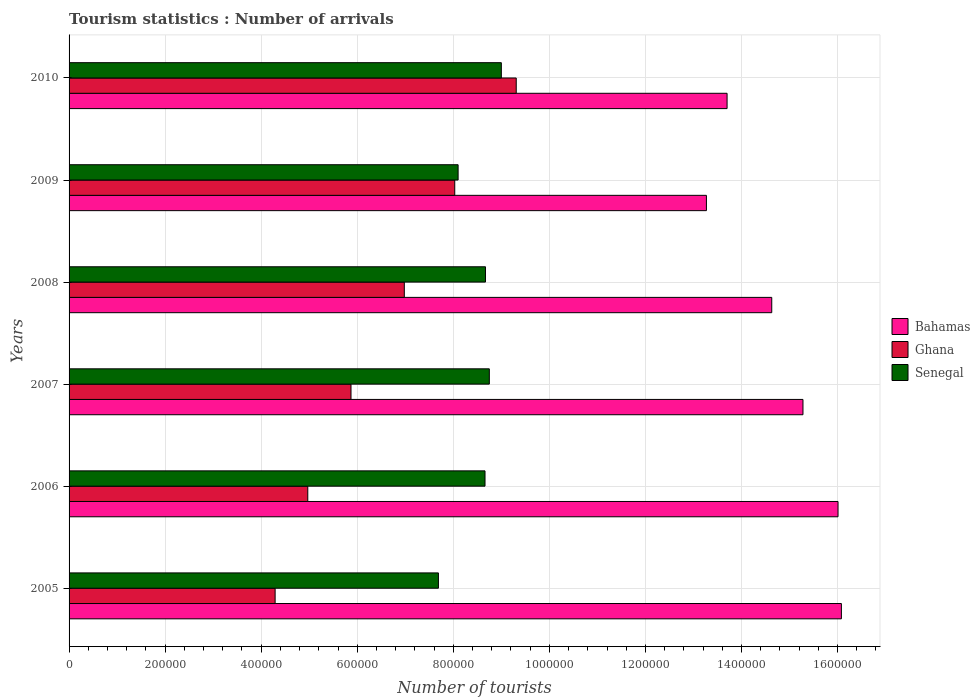How many different coloured bars are there?
Offer a terse response. 3. How many groups of bars are there?
Make the answer very short. 6. Are the number of bars per tick equal to the number of legend labels?
Give a very brief answer. Yes. How many bars are there on the 6th tick from the bottom?
Provide a short and direct response. 3. What is the label of the 2nd group of bars from the top?
Keep it short and to the point. 2009. What is the number of tourist arrivals in Senegal in 2008?
Your answer should be very brief. 8.67e+05. Across all years, what is the maximum number of tourist arrivals in Ghana?
Your answer should be very brief. 9.31e+05. Across all years, what is the minimum number of tourist arrivals in Ghana?
Offer a very short reply. 4.29e+05. What is the total number of tourist arrivals in Senegal in the graph?
Your response must be concise. 5.09e+06. What is the difference between the number of tourist arrivals in Senegal in 2005 and that in 2010?
Your answer should be very brief. -1.31e+05. What is the difference between the number of tourist arrivals in Bahamas in 2005 and the number of tourist arrivals in Ghana in 2008?
Give a very brief answer. 9.10e+05. What is the average number of tourist arrivals in Senegal per year?
Ensure brevity in your answer.  8.48e+05. In the year 2010, what is the difference between the number of tourist arrivals in Bahamas and number of tourist arrivals in Ghana?
Keep it short and to the point. 4.39e+05. What is the ratio of the number of tourist arrivals in Senegal in 2005 to that in 2009?
Give a very brief answer. 0.95. Is the number of tourist arrivals in Ghana in 2006 less than that in 2009?
Your response must be concise. Yes. Is the difference between the number of tourist arrivals in Bahamas in 2006 and 2009 greater than the difference between the number of tourist arrivals in Ghana in 2006 and 2009?
Make the answer very short. Yes. What is the difference between the highest and the second highest number of tourist arrivals in Ghana?
Provide a succinct answer. 1.28e+05. What is the difference between the highest and the lowest number of tourist arrivals in Bahamas?
Keep it short and to the point. 2.81e+05. What does the 2nd bar from the bottom in 2010 represents?
Keep it short and to the point. Ghana. Is it the case that in every year, the sum of the number of tourist arrivals in Senegal and number of tourist arrivals in Bahamas is greater than the number of tourist arrivals in Ghana?
Keep it short and to the point. Yes. Are all the bars in the graph horizontal?
Provide a succinct answer. Yes. Are the values on the major ticks of X-axis written in scientific E-notation?
Your response must be concise. No. Does the graph contain any zero values?
Your answer should be compact. No. Does the graph contain grids?
Offer a terse response. Yes. Where does the legend appear in the graph?
Offer a very short reply. Center right. How many legend labels are there?
Your response must be concise. 3. What is the title of the graph?
Provide a succinct answer. Tourism statistics : Number of arrivals. What is the label or title of the X-axis?
Provide a succinct answer. Number of tourists. What is the label or title of the Y-axis?
Your response must be concise. Years. What is the Number of tourists in Bahamas in 2005?
Offer a very short reply. 1.61e+06. What is the Number of tourists of Ghana in 2005?
Make the answer very short. 4.29e+05. What is the Number of tourists in Senegal in 2005?
Offer a terse response. 7.69e+05. What is the Number of tourists in Bahamas in 2006?
Ensure brevity in your answer.  1.60e+06. What is the Number of tourists in Ghana in 2006?
Offer a terse response. 4.97e+05. What is the Number of tourists in Senegal in 2006?
Offer a terse response. 8.66e+05. What is the Number of tourists of Bahamas in 2007?
Keep it short and to the point. 1.53e+06. What is the Number of tourists in Ghana in 2007?
Make the answer very short. 5.87e+05. What is the Number of tourists in Senegal in 2007?
Make the answer very short. 8.75e+05. What is the Number of tourists in Bahamas in 2008?
Offer a terse response. 1.46e+06. What is the Number of tourists of Ghana in 2008?
Your answer should be very brief. 6.98e+05. What is the Number of tourists in Senegal in 2008?
Provide a succinct answer. 8.67e+05. What is the Number of tourists of Bahamas in 2009?
Provide a succinct answer. 1.33e+06. What is the Number of tourists of Ghana in 2009?
Offer a terse response. 8.03e+05. What is the Number of tourists of Senegal in 2009?
Give a very brief answer. 8.10e+05. What is the Number of tourists of Bahamas in 2010?
Keep it short and to the point. 1.37e+06. What is the Number of tourists in Ghana in 2010?
Offer a terse response. 9.31e+05. What is the Number of tourists in Senegal in 2010?
Your response must be concise. 9.00e+05. Across all years, what is the maximum Number of tourists in Bahamas?
Provide a short and direct response. 1.61e+06. Across all years, what is the maximum Number of tourists in Ghana?
Offer a very short reply. 9.31e+05. Across all years, what is the minimum Number of tourists in Bahamas?
Offer a very short reply. 1.33e+06. Across all years, what is the minimum Number of tourists in Ghana?
Offer a very short reply. 4.29e+05. Across all years, what is the minimum Number of tourists in Senegal?
Provide a short and direct response. 7.69e+05. What is the total Number of tourists of Bahamas in the graph?
Your answer should be very brief. 8.90e+06. What is the total Number of tourists of Ghana in the graph?
Provide a succinct answer. 3.94e+06. What is the total Number of tourists of Senegal in the graph?
Ensure brevity in your answer.  5.09e+06. What is the difference between the Number of tourists of Bahamas in 2005 and that in 2006?
Your answer should be compact. 7000. What is the difference between the Number of tourists of Ghana in 2005 and that in 2006?
Offer a very short reply. -6.80e+04. What is the difference between the Number of tourists in Senegal in 2005 and that in 2006?
Provide a succinct answer. -9.70e+04. What is the difference between the Number of tourists in Bahamas in 2005 and that in 2007?
Your response must be concise. 8.00e+04. What is the difference between the Number of tourists of Ghana in 2005 and that in 2007?
Make the answer very short. -1.58e+05. What is the difference between the Number of tourists of Senegal in 2005 and that in 2007?
Your response must be concise. -1.06e+05. What is the difference between the Number of tourists of Bahamas in 2005 and that in 2008?
Ensure brevity in your answer.  1.45e+05. What is the difference between the Number of tourists of Ghana in 2005 and that in 2008?
Offer a terse response. -2.69e+05. What is the difference between the Number of tourists in Senegal in 2005 and that in 2008?
Provide a succinct answer. -9.80e+04. What is the difference between the Number of tourists of Bahamas in 2005 and that in 2009?
Your answer should be very brief. 2.81e+05. What is the difference between the Number of tourists of Ghana in 2005 and that in 2009?
Your answer should be very brief. -3.74e+05. What is the difference between the Number of tourists of Senegal in 2005 and that in 2009?
Your answer should be compact. -4.10e+04. What is the difference between the Number of tourists in Bahamas in 2005 and that in 2010?
Your answer should be compact. 2.38e+05. What is the difference between the Number of tourists in Ghana in 2005 and that in 2010?
Offer a very short reply. -5.02e+05. What is the difference between the Number of tourists in Senegal in 2005 and that in 2010?
Give a very brief answer. -1.31e+05. What is the difference between the Number of tourists of Bahamas in 2006 and that in 2007?
Offer a very short reply. 7.30e+04. What is the difference between the Number of tourists in Senegal in 2006 and that in 2007?
Make the answer very short. -9000. What is the difference between the Number of tourists of Bahamas in 2006 and that in 2008?
Provide a short and direct response. 1.38e+05. What is the difference between the Number of tourists of Ghana in 2006 and that in 2008?
Give a very brief answer. -2.01e+05. What is the difference between the Number of tourists of Senegal in 2006 and that in 2008?
Your answer should be very brief. -1000. What is the difference between the Number of tourists of Bahamas in 2006 and that in 2009?
Make the answer very short. 2.74e+05. What is the difference between the Number of tourists of Ghana in 2006 and that in 2009?
Offer a very short reply. -3.06e+05. What is the difference between the Number of tourists of Senegal in 2006 and that in 2009?
Provide a succinct answer. 5.60e+04. What is the difference between the Number of tourists in Bahamas in 2006 and that in 2010?
Your answer should be compact. 2.31e+05. What is the difference between the Number of tourists in Ghana in 2006 and that in 2010?
Keep it short and to the point. -4.34e+05. What is the difference between the Number of tourists in Senegal in 2006 and that in 2010?
Provide a succinct answer. -3.40e+04. What is the difference between the Number of tourists of Bahamas in 2007 and that in 2008?
Make the answer very short. 6.50e+04. What is the difference between the Number of tourists of Ghana in 2007 and that in 2008?
Keep it short and to the point. -1.11e+05. What is the difference between the Number of tourists of Senegal in 2007 and that in 2008?
Keep it short and to the point. 8000. What is the difference between the Number of tourists in Bahamas in 2007 and that in 2009?
Ensure brevity in your answer.  2.01e+05. What is the difference between the Number of tourists in Ghana in 2007 and that in 2009?
Your response must be concise. -2.16e+05. What is the difference between the Number of tourists in Senegal in 2007 and that in 2009?
Offer a terse response. 6.50e+04. What is the difference between the Number of tourists in Bahamas in 2007 and that in 2010?
Make the answer very short. 1.58e+05. What is the difference between the Number of tourists in Ghana in 2007 and that in 2010?
Your response must be concise. -3.44e+05. What is the difference between the Number of tourists of Senegal in 2007 and that in 2010?
Provide a short and direct response. -2.50e+04. What is the difference between the Number of tourists in Bahamas in 2008 and that in 2009?
Keep it short and to the point. 1.36e+05. What is the difference between the Number of tourists of Ghana in 2008 and that in 2009?
Your response must be concise. -1.05e+05. What is the difference between the Number of tourists of Senegal in 2008 and that in 2009?
Keep it short and to the point. 5.70e+04. What is the difference between the Number of tourists in Bahamas in 2008 and that in 2010?
Offer a very short reply. 9.30e+04. What is the difference between the Number of tourists in Ghana in 2008 and that in 2010?
Give a very brief answer. -2.33e+05. What is the difference between the Number of tourists in Senegal in 2008 and that in 2010?
Make the answer very short. -3.30e+04. What is the difference between the Number of tourists of Bahamas in 2009 and that in 2010?
Your answer should be very brief. -4.30e+04. What is the difference between the Number of tourists of Ghana in 2009 and that in 2010?
Provide a short and direct response. -1.28e+05. What is the difference between the Number of tourists of Bahamas in 2005 and the Number of tourists of Ghana in 2006?
Your answer should be very brief. 1.11e+06. What is the difference between the Number of tourists in Bahamas in 2005 and the Number of tourists in Senegal in 2006?
Your response must be concise. 7.42e+05. What is the difference between the Number of tourists of Ghana in 2005 and the Number of tourists of Senegal in 2006?
Your response must be concise. -4.37e+05. What is the difference between the Number of tourists of Bahamas in 2005 and the Number of tourists of Ghana in 2007?
Offer a terse response. 1.02e+06. What is the difference between the Number of tourists in Bahamas in 2005 and the Number of tourists in Senegal in 2007?
Ensure brevity in your answer.  7.33e+05. What is the difference between the Number of tourists of Ghana in 2005 and the Number of tourists of Senegal in 2007?
Your answer should be very brief. -4.46e+05. What is the difference between the Number of tourists of Bahamas in 2005 and the Number of tourists of Ghana in 2008?
Ensure brevity in your answer.  9.10e+05. What is the difference between the Number of tourists in Bahamas in 2005 and the Number of tourists in Senegal in 2008?
Your answer should be very brief. 7.41e+05. What is the difference between the Number of tourists in Ghana in 2005 and the Number of tourists in Senegal in 2008?
Provide a succinct answer. -4.38e+05. What is the difference between the Number of tourists in Bahamas in 2005 and the Number of tourists in Ghana in 2009?
Your answer should be compact. 8.05e+05. What is the difference between the Number of tourists of Bahamas in 2005 and the Number of tourists of Senegal in 2009?
Ensure brevity in your answer.  7.98e+05. What is the difference between the Number of tourists in Ghana in 2005 and the Number of tourists in Senegal in 2009?
Your answer should be very brief. -3.81e+05. What is the difference between the Number of tourists in Bahamas in 2005 and the Number of tourists in Ghana in 2010?
Your answer should be compact. 6.77e+05. What is the difference between the Number of tourists of Bahamas in 2005 and the Number of tourists of Senegal in 2010?
Ensure brevity in your answer.  7.08e+05. What is the difference between the Number of tourists in Ghana in 2005 and the Number of tourists in Senegal in 2010?
Your answer should be compact. -4.71e+05. What is the difference between the Number of tourists of Bahamas in 2006 and the Number of tourists of Ghana in 2007?
Keep it short and to the point. 1.01e+06. What is the difference between the Number of tourists of Bahamas in 2006 and the Number of tourists of Senegal in 2007?
Offer a very short reply. 7.26e+05. What is the difference between the Number of tourists of Ghana in 2006 and the Number of tourists of Senegal in 2007?
Make the answer very short. -3.78e+05. What is the difference between the Number of tourists of Bahamas in 2006 and the Number of tourists of Ghana in 2008?
Provide a succinct answer. 9.03e+05. What is the difference between the Number of tourists of Bahamas in 2006 and the Number of tourists of Senegal in 2008?
Give a very brief answer. 7.34e+05. What is the difference between the Number of tourists of Ghana in 2006 and the Number of tourists of Senegal in 2008?
Offer a terse response. -3.70e+05. What is the difference between the Number of tourists in Bahamas in 2006 and the Number of tourists in Ghana in 2009?
Your answer should be very brief. 7.98e+05. What is the difference between the Number of tourists of Bahamas in 2006 and the Number of tourists of Senegal in 2009?
Provide a succinct answer. 7.91e+05. What is the difference between the Number of tourists of Ghana in 2006 and the Number of tourists of Senegal in 2009?
Make the answer very short. -3.13e+05. What is the difference between the Number of tourists of Bahamas in 2006 and the Number of tourists of Ghana in 2010?
Your response must be concise. 6.70e+05. What is the difference between the Number of tourists of Bahamas in 2006 and the Number of tourists of Senegal in 2010?
Offer a terse response. 7.01e+05. What is the difference between the Number of tourists of Ghana in 2006 and the Number of tourists of Senegal in 2010?
Offer a very short reply. -4.03e+05. What is the difference between the Number of tourists in Bahamas in 2007 and the Number of tourists in Ghana in 2008?
Offer a terse response. 8.30e+05. What is the difference between the Number of tourists of Bahamas in 2007 and the Number of tourists of Senegal in 2008?
Ensure brevity in your answer.  6.61e+05. What is the difference between the Number of tourists of Ghana in 2007 and the Number of tourists of Senegal in 2008?
Ensure brevity in your answer.  -2.80e+05. What is the difference between the Number of tourists in Bahamas in 2007 and the Number of tourists in Ghana in 2009?
Ensure brevity in your answer.  7.25e+05. What is the difference between the Number of tourists of Bahamas in 2007 and the Number of tourists of Senegal in 2009?
Offer a very short reply. 7.18e+05. What is the difference between the Number of tourists of Ghana in 2007 and the Number of tourists of Senegal in 2009?
Your answer should be very brief. -2.23e+05. What is the difference between the Number of tourists in Bahamas in 2007 and the Number of tourists in Ghana in 2010?
Your answer should be very brief. 5.97e+05. What is the difference between the Number of tourists of Bahamas in 2007 and the Number of tourists of Senegal in 2010?
Your answer should be compact. 6.28e+05. What is the difference between the Number of tourists in Ghana in 2007 and the Number of tourists in Senegal in 2010?
Your answer should be compact. -3.13e+05. What is the difference between the Number of tourists in Bahamas in 2008 and the Number of tourists in Ghana in 2009?
Your response must be concise. 6.60e+05. What is the difference between the Number of tourists in Bahamas in 2008 and the Number of tourists in Senegal in 2009?
Give a very brief answer. 6.53e+05. What is the difference between the Number of tourists in Ghana in 2008 and the Number of tourists in Senegal in 2009?
Give a very brief answer. -1.12e+05. What is the difference between the Number of tourists in Bahamas in 2008 and the Number of tourists in Ghana in 2010?
Ensure brevity in your answer.  5.32e+05. What is the difference between the Number of tourists of Bahamas in 2008 and the Number of tourists of Senegal in 2010?
Give a very brief answer. 5.63e+05. What is the difference between the Number of tourists of Ghana in 2008 and the Number of tourists of Senegal in 2010?
Give a very brief answer. -2.02e+05. What is the difference between the Number of tourists of Bahamas in 2009 and the Number of tourists of Ghana in 2010?
Offer a terse response. 3.96e+05. What is the difference between the Number of tourists in Bahamas in 2009 and the Number of tourists in Senegal in 2010?
Your answer should be compact. 4.27e+05. What is the difference between the Number of tourists of Ghana in 2009 and the Number of tourists of Senegal in 2010?
Keep it short and to the point. -9.70e+04. What is the average Number of tourists of Bahamas per year?
Give a very brief answer. 1.48e+06. What is the average Number of tourists of Ghana per year?
Make the answer very short. 6.58e+05. What is the average Number of tourists of Senegal per year?
Keep it short and to the point. 8.48e+05. In the year 2005, what is the difference between the Number of tourists of Bahamas and Number of tourists of Ghana?
Offer a very short reply. 1.18e+06. In the year 2005, what is the difference between the Number of tourists in Bahamas and Number of tourists in Senegal?
Offer a very short reply. 8.39e+05. In the year 2006, what is the difference between the Number of tourists in Bahamas and Number of tourists in Ghana?
Offer a terse response. 1.10e+06. In the year 2006, what is the difference between the Number of tourists of Bahamas and Number of tourists of Senegal?
Provide a succinct answer. 7.35e+05. In the year 2006, what is the difference between the Number of tourists of Ghana and Number of tourists of Senegal?
Provide a succinct answer. -3.69e+05. In the year 2007, what is the difference between the Number of tourists in Bahamas and Number of tourists in Ghana?
Your response must be concise. 9.41e+05. In the year 2007, what is the difference between the Number of tourists of Bahamas and Number of tourists of Senegal?
Your answer should be compact. 6.53e+05. In the year 2007, what is the difference between the Number of tourists of Ghana and Number of tourists of Senegal?
Your answer should be very brief. -2.88e+05. In the year 2008, what is the difference between the Number of tourists in Bahamas and Number of tourists in Ghana?
Ensure brevity in your answer.  7.65e+05. In the year 2008, what is the difference between the Number of tourists in Bahamas and Number of tourists in Senegal?
Keep it short and to the point. 5.96e+05. In the year 2008, what is the difference between the Number of tourists of Ghana and Number of tourists of Senegal?
Offer a terse response. -1.69e+05. In the year 2009, what is the difference between the Number of tourists of Bahamas and Number of tourists of Ghana?
Offer a terse response. 5.24e+05. In the year 2009, what is the difference between the Number of tourists in Bahamas and Number of tourists in Senegal?
Ensure brevity in your answer.  5.17e+05. In the year 2009, what is the difference between the Number of tourists of Ghana and Number of tourists of Senegal?
Make the answer very short. -7000. In the year 2010, what is the difference between the Number of tourists in Bahamas and Number of tourists in Ghana?
Offer a very short reply. 4.39e+05. In the year 2010, what is the difference between the Number of tourists in Bahamas and Number of tourists in Senegal?
Keep it short and to the point. 4.70e+05. In the year 2010, what is the difference between the Number of tourists of Ghana and Number of tourists of Senegal?
Provide a succinct answer. 3.10e+04. What is the ratio of the Number of tourists in Bahamas in 2005 to that in 2006?
Your answer should be very brief. 1. What is the ratio of the Number of tourists in Ghana in 2005 to that in 2006?
Make the answer very short. 0.86. What is the ratio of the Number of tourists in Senegal in 2005 to that in 2006?
Provide a short and direct response. 0.89. What is the ratio of the Number of tourists in Bahamas in 2005 to that in 2007?
Offer a terse response. 1.05. What is the ratio of the Number of tourists in Ghana in 2005 to that in 2007?
Offer a terse response. 0.73. What is the ratio of the Number of tourists of Senegal in 2005 to that in 2007?
Give a very brief answer. 0.88. What is the ratio of the Number of tourists of Bahamas in 2005 to that in 2008?
Your answer should be compact. 1.1. What is the ratio of the Number of tourists of Ghana in 2005 to that in 2008?
Offer a terse response. 0.61. What is the ratio of the Number of tourists in Senegal in 2005 to that in 2008?
Keep it short and to the point. 0.89. What is the ratio of the Number of tourists in Bahamas in 2005 to that in 2009?
Your answer should be very brief. 1.21. What is the ratio of the Number of tourists of Ghana in 2005 to that in 2009?
Your answer should be compact. 0.53. What is the ratio of the Number of tourists in Senegal in 2005 to that in 2009?
Offer a very short reply. 0.95. What is the ratio of the Number of tourists of Bahamas in 2005 to that in 2010?
Provide a succinct answer. 1.17. What is the ratio of the Number of tourists of Ghana in 2005 to that in 2010?
Ensure brevity in your answer.  0.46. What is the ratio of the Number of tourists of Senegal in 2005 to that in 2010?
Provide a short and direct response. 0.85. What is the ratio of the Number of tourists in Bahamas in 2006 to that in 2007?
Your answer should be very brief. 1.05. What is the ratio of the Number of tourists in Ghana in 2006 to that in 2007?
Give a very brief answer. 0.85. What is the ratio of the Number of tourists of Bahamas in 2006 to that in 2008?
Give a very brief answer. 1.09. What is the ratio of the Number of tourists of Ghana in 2006 to that in 2008?
Make the answer very short. 0.71. What is the ratio of the Number of tourists in Senegal in 2006 to that in 2008?
Offer a very short reply. 1. What is the ratio of the Number of tourists of Bahamas in 2006 to that in 2009?
Keep it short and to the point. 1.21. What is the ratio of the Number of tourists of Ghana in 2006 to that in 2009?
Offer a very short reply. 0.62. What is the ratio of the Number of tourists in Senegal in 2006 to that in 2009?
Make the answer very short. 1.07. What is the ratio of the Number of tourists in Bahamas in 2006 to that in 2010?
Make the answer very short. 1.17. What is the ratio of the Number of tourists of Ghana in 2006 to that in 2010?
Your answer should be compact. 0.53. What is the ratio of the Number of tourists in Senegal in 2006 to that in 2010?
Give a very brief answer. 0.96. What is the ratio of the Number of tourists in Bahamas in 2007 to that in 2008?
Provide a short and direct response. 1.04. What is the ratio of the Number of tourists in Ghana in 2007 to that in 2008?
Provide a succinct answer. 0.84. What is the ratio of the Number of tourists of Senegal in 2007 to that in 2008?
Your answer should be compact. 1.01. What is the ratio of the Number of tourists in Bahamas in 2007 to that in 2009?
Keep it short and to the point. 1.15. What is the ratio of the Number of tourists of Ghana in 2007 to that in 2009?
Give a very brief answer. 0.73. What is the ratio of the Number of tourists of Senegal in 2007 to that in 2009?
Offer a terse response. 1.08. What is the ratio of the Number of tourists of Bahamas in 2007 to that in 2010?
Give a very brief answer. 1.12. What is the ratio of the Number of tourists in Ghana in 2007 to that in 2010?
Offer a very short reply. 0.63. What is the ratio of the Number of tourists of Senegal in 2007 to that in 2010?
Give a very brief answer. 0.97. What is the ratio of the Number of tourists of Bahamas in 2008 to that in 2009?
Ensure brevity in your answer.  1.1. What is the ratio of the Number of tourists of Ghana in 2008 to that in 2009?
Your response must be concise. 0.87. What is the ratio of the Number of tourists of Senegal in 2008 to that in 2009?
Give a very brief answer. 1.07. What is the ratio of the Number of tourists in Bahamas in 2008 to that in 2010?
Your response must be concise. 1.07. What is the ratio of the Number of tourists of Ghana in 2008 to that in 2010?
Keep it short and to the point. 0.75. What is the ratio of the Number of tourists of Senegal in 2008 to that in 2010?
Provide a succinct answer. 0.96. What is the ratio of the Number of tourists of Bahamas in 2009 to that in 2010?
Provide a succinct answer. 0.97. What is the ratio of the Number of tourists of Ghana in 2009 to that in 2010?
Offer a terse response. 0.86. What is the ratio of the Number of tourists of Senegal in 2009 to that in 2010?
Ensure brevity in your answer.  0.9. What is the difference between the highest and the second highest Number of tourists in Bahamas?
Ensure brevity in your answer.  7000. What is the difference between the highest and the second highest Number of tourists of Ghana?
Offer a terse response. 1.28e+05. What is the difference between the highest and the second highest Number of tourists of Senegal?
Keep it short and to the point. 2.50e+04. What is the difference between the highest and the lowest Number of tourists of Bahamas?
Provide a succinct answer. 2.81e+05. What is the difference between the highest and the lowest Number of tourists in Ghana?
Provide a short and direct response. 5.02e+05. What is the difference between the highest and the lowest Number of tourists of Senegal?
Provide a short and direct response. 1.31e+05. 